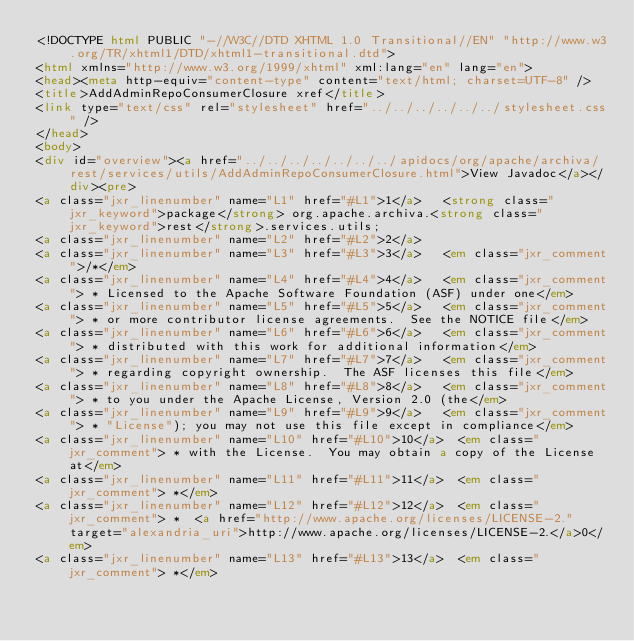Convert code to text. <code><loc_0><loc_0><loc_500><loc_500><_HTML_><!DOCTYPE html PUBLIC "-//W3C//DTD XHTML 1.0 Transitional//EN" "http://www.w3.org/TR/xhtml1/DTD/xhtml1-transitional.dtd">
<html xmlns="http://www.w3.org/1999/xhtml" xml:lang="en" lang="en">
<head><meta http-equiv="content-type" content="text/html; charset=UTF-8" />
<title>AddAdminRepoConsumerClosure xref</title>
<link type="text/css" rel="stylesheet" href="../../../../../../stylesheet.css" />
</head>
<body>
<div id="overview"><a href="../../../../../../../apidocs/org/apache/archiva/rest/services/utils/AddAdminRepoConsumerClosure.html">View Javadoc</a></div><pre>
<a class="jxr_linenumber" name="L1" href="#L1">1</a>   <strong class="jxr_keyword">package</strong> org.apache.archiva.<strong class="jxr_keyword">rest</strong>.services.utils;
<a class="jxr_linenumber" name="L2" href="#L2">2</a>   
<a class="jxr_linenumber" name="L3" href="#L3">3</a>   <em class="jxr_comment">/*</em>
<a class="jxr_linenumber" name="L4" href="#L4">4</a>   <em class="jxr_comment"> * Licensed to the Apache Software Foundation (ASF) under one</em>
<a class="jxr_linenumber" name="L5" href="#L5">5</a>   <em class="jxr_comment"> * or more contributor license agreements.  See the NOTICE file</em>
<a class="jxr_linenumber" name="L6" href="#L6">6</a>   <em class="jxr_comment"> * distributed with this work for additional information</em>
<a class="jxr_linenumber" name="L7" href="#L7">7</a>   <em class="jxr_comment"> * regarding copyright ownership.  The ASF licenses this file</em>
<a class="jxr_linenumber" name="L8" href="#L8">8</a>   <em class="jxr_comment"> * to you under the Apache License, Version 2.0 (the</em>
<a class="jxr_linenumber" name="L9" href="#L9">9</a>   <em class="jxr_comment"> * "License"); you may not use this file except in compliance</em>
<a class="jxr_linenumber" name="L10" href="#L10">10</a>  <em class="jxr_comment"> * with the License.  You may obtain a copy of the License at</em>
<a class="jxr_linenumber" name="L11" href="#L11">11</a>  <em class="jxr_comment"> *</em>
<a class="jxr_linenumber" name="L12" href="#L12">12</a>  <em class="jxr_comment"> *  <a href="http://www.apache.org/licenses/LICENSE-2." target="alexandria_uri">http://www.apache.org/licenses/LICENSE-2.</a>0</em>
<a class="jxr_linenumber" name="L13" href="#L13">13</a>  <em class="jxr_comment"> *</em></code> 